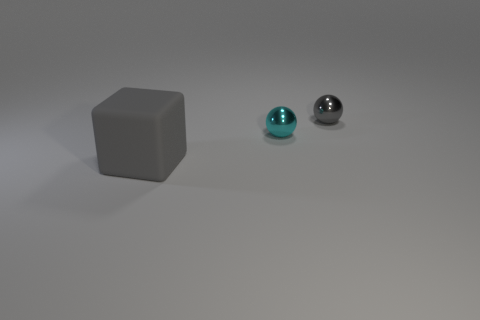Add 1 rubber things. How many objects exist? 4 Subtract 1 balls. How many balls are left? 1 Subtract all balls. How many objects are left? 1 Add 2 tiny gray metal things. How many tiny gray metal things exist? 3 Subtract 0 yellow spheres. How many objects are left? 3 Subtract all yellow spheres. Subtract all green cylinders. How many spheres are left? 2 Subtract all gray metal spheres. Subtract all big gray rubber blocks. How many objects are left? 1 Add 1 gray cubes. How many gray cubes are left? 2 